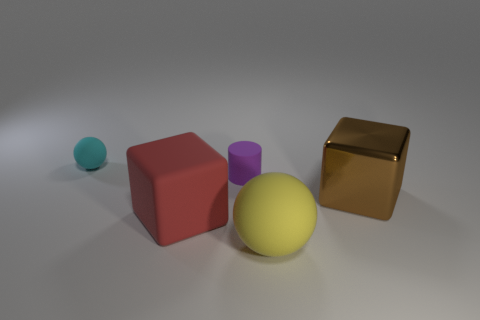Add 1 balls. How many objects exist? 6 Subtract all blocks. How many objects are left? 3 Subtract 0 red cylinders. How many objects are left? 5 Subtract all tiny balls. Subtract all big metal cylinders. How many objects are left? 4 Add 4 matte balls. How many matte balls are left? 6 Add 3 brown blocks. How many brown blocks exist? 4 